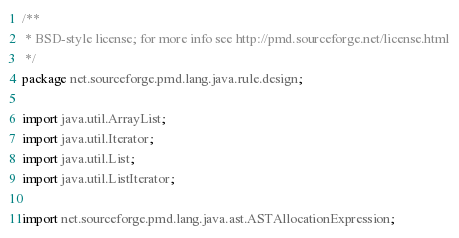<code> <loc_0><loc_0><loc_500><loc_500><_Java_>/**
 * BSD-style license; for more info see http://pmd.sourceforge.net/license.html
 */
package net.sourceforge.pmd.lang.java.rule.design;

import java.util.ArrayList;
import java.util.Iterator;
import java.util.List;
import java.util.ListIterator;

import net.sourceforge.pmd.lang.java.ast.ASTAllocationExpression;</code> 